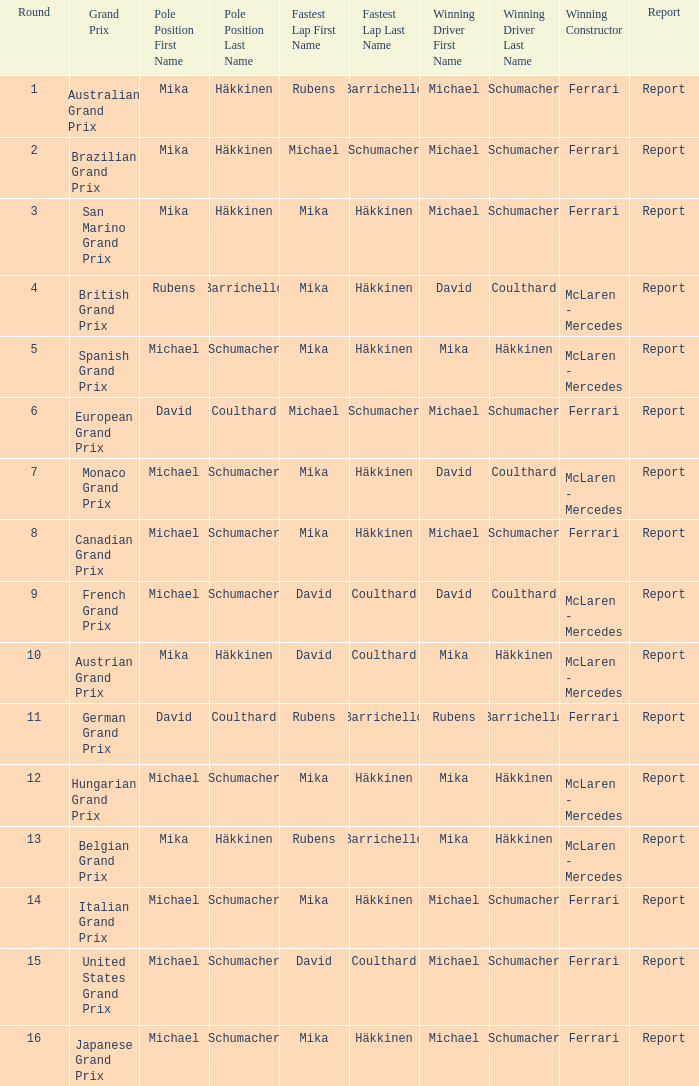In what round did michael schumacher hold the pole position, david coulthard complete the speediest lap, and mclaren - mercedes become the triumphant constructor? 1.0. 